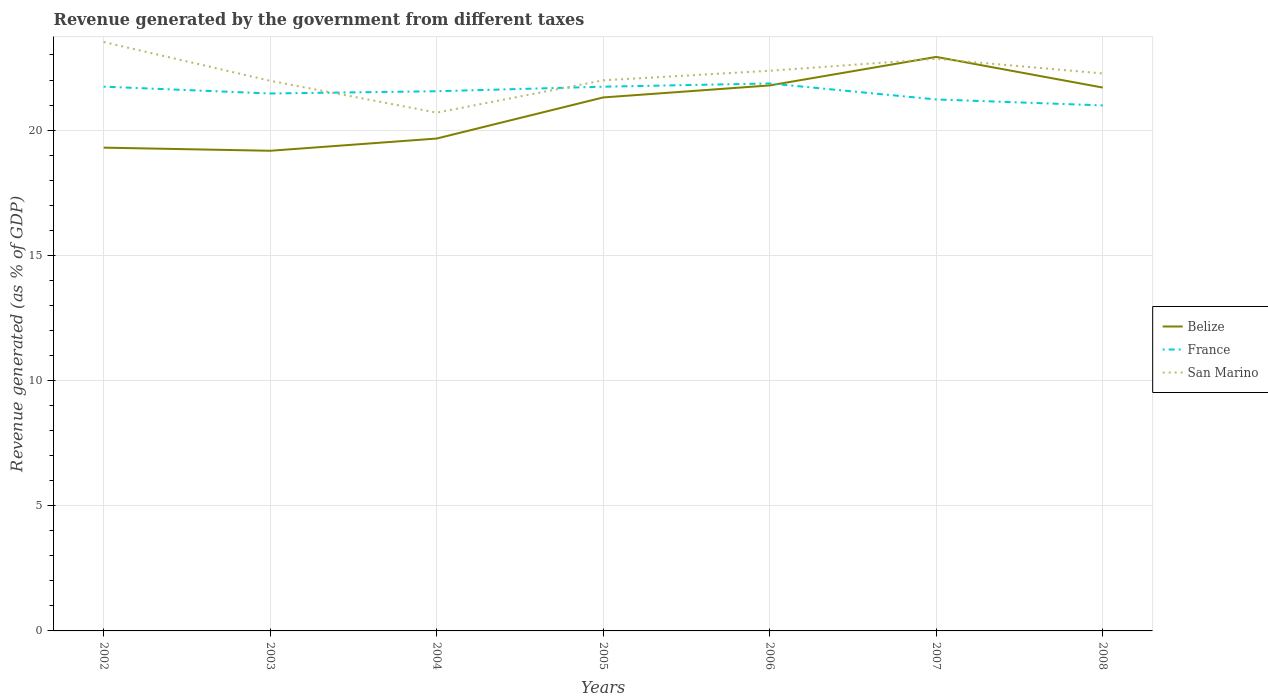Does the line corresponding to Belize intersect with the line corresponding to France?
Give a very brief answer. Yes. Across all years, what is the maximum revenue generated by the government in San Marino?
Make the answer very short. 20.7. In which year was the revenue generated by the government in San Marino maximum?
Offer a very short reply. 2004. What is the total revenue generated by the government in France in the graph?
Offer a very short reply. 0.64. What is the difference between the highest and the second highest revenue generated by the government in San Marino?
Provide a short and direct response. 2.82. How many lines are there?
Give a very brief answer. 3. What is the difference between two consecutive major ticks on the Y-axis?
Your answer should be compact. 5. Does the graph contain any zero values?
Your answer should be compact. No. Does the graph contain grids?
Your response must be concise. Yes. Where does the legend appear in the graph?
Ensure brevity in your answer.  Center right. How many legend labels are there?
Give a very brief answer. 3. How are the legend labels stacked?
Your answer should be very brief. Vertical. What is the title of the graph?
Offer a terse response. Revenue generated by the government from different taxes. What is the label or title of the Y-axis?
Your response must be concise. Revenue generated (as % of GDP). What is the Revenue generated (as % of GDP) in Belize in 2002?
Provide a succinct answer. 19.3. What is the Revenue generated (as % of GDP) of France in 2002?
Your answer should be compact. 21.74. What is the Revenue generated (as % of GDP) of San Marino in 2002?
Ensure brevity in your answer.  23.52. What is the Revenue generated (as % of GDP) in Belize in 2003?
Keep it short and to the point. 19.17. What is the Revenue generated (as % of GDP) of France in 2003?
Offer a terse response. 21.46. What is the Revenue generated (as % of GDP) of San Marino in 2003?
Your response must be concise. 21.97. What is the Revenue generated (as % of GDP) of Belize in 2004?
Ensure brevity in your answer.  19.66. What is the Revenue generated (as % of GDP) of France in 2004?
Your answer should be very brief. 21.55. What is the Revenue generated (as % of GDP) of San Marino in 2004?
Offer a very short reply. 20.7. What is the Revenue generated (as % of GDP) of Belize in 2005?
Your answer should be very brief. 21.3. What is the Revenue generated (as % of GDP) in France in 2005?
Your answer should be very brief. 21.73. What is the Revenue generated (as % of GDP) of San Marino in 2005?
Your response must be concise. 21.99. What is the Revenue generated (as % of GDP) of Belize in 2006?
Your answer should be compact. 21.78. What is the Revenue generated (as % of GDP) of France in 2006?
Ensure brevity in your answer.  21.86. What is the Revenue generated (as % of GDP) of San Marino in 2006?
Keep it short and to the point. 22.37. What is the Revenue generated (as % of GDP) of Belize in 2007?
Offer a terse response. 22.92. What is the Revenue generated (as % of GDP) of France in 2007?
Your response must be concise. 21.22. What is the Revenue generated (as % of GDP) of San Marino in 2007?
Keep it short and to the point. 22.85. What is the Revenue generated (as % of GDP) in Belize in 2008?
Provide a short and direct response. 21.7. What is the Revenue generated (as % of GDP) in France in 2008?
Provide a succinct answer. 20.99. What is the Revenue generated (as % of GDP) in San Marino in 2008?
Make the answer very short. 22.26. Across all years, what is the maximum Revenue generated (as % of GDP) of Belize?
Provide a short and direct response. 22.92. Across all years, what is the maximum Revenue generated (as % of GDP) of France?
Offer a very short reply. 21.86. Across all years, what is the maximum Revenue generated (as % of GDP) of San Marino?
Make the answer very short. 23.52. Across all years, what is the minimum Revenue generated (as % of GDP) of Belize?
Offer a very short reply. 19.17. Across all years, what is the minimum Revenue generated (as % of GDP) of France?
Make the answer very short. 20.99. Across all years, what is the minimum Revenue generated (as % of GDP) in San Marino?
Your answer should be compact. 20.7. What is the total Revenue generated (as % of GDP) in Belize in the graph?
Your response must be concise. 145.85. What is the total Revenue generated (as % of GDP) of France in the graph?
Make the answer very short. 150.56. What is the total Revenue generated (as % of GDP) of San Marino in the graph?
Give a very brief answer. 155.65. What is the difference between the Revenue generated (as % of GDP) in Belize in 2002 and that in 2003?
Offer a very short reply. 0.12. What is the difference between the Revenue generated (as % of GDP) in France in 2002 and that in 2003?
Make the answer very short. 0.27. What is the difference between the Revenue generated (as % of GDP) in San Marino in 2002 and that in 2003?
Give a very brief answer. 1.55. What is the difference between the Revenue generated (as % of GDP) of Belize in 2002 and that in 2004?
Your answer should be compact. -0.36. What is the difference between the Revenue generated (as % of GDP) in France in 2002 and that in 2004?
Make the answer very short. 0.18. What is the difference between the Revenue generated (as % of GDP) of San Marino in 2002 and that in 2004?
Make the answer very short. 2.82. What is the difference between the Revenue generated (as % of GDP) of Belize in 2002 and that in 2005?
Make the answer very short. -2. What is the difference between the Revenue generated (as % of GDP) in France in 2002 and that in 2005?
Your answer should be compact. 0. What is the difference between the Revenue generated (as % of GDP) of San Marino in 2002 and that in 2005?
Give a very brief answer. 1.53. What is the difference between the Revenue generated (as % of GDP) in Belize in 2002 and that in 2006?
Offer a very short reply. -2.48. What is the difference between the Revenue generated (as % of GDP) of France in 2002 and that in 2006?
Give a very brief answer. -0.13. What is the difference between the Revenue generated (as % of GDP) in San Marino in 2002 and that in 2006?
Provide a short and direct response. 1.15. What is the difference between the Revenue generated (as % of GDP) of Belize in 2002 and that in 2007?
Your answer should be compact. -3.62. What is the difference between the Revenue generated (as % of GDP) of France in 2002 and that in 2007?
Keep it short and to the point. 0.51. What is the difference between the Revenue generated (as % of GDP) of San Marino in 2002 and that in 2007?
Your answer should be compact. 0.67. What is the difference between the Revenue generated (as % of GDP) of Belize in 2002 and that in 2008?
Provide a succinct answer. -2.4. What is the difference between the Revenue generated (as % of GDP) of France in 2002 and that in 2008?
Your response must be concise. 0.75. What is the difference between the Revenue generated (as % of GDP) of San Marino in 2002 and that in 2008?
Provide a short and direct response. 1.26. What is the difference between the Revenue generated (as % of GDP) of Belize in 2003 and that in 2004?
Make the answer very short. -0.49. What is the difference between the Revenue generated (as % of GDP) of France in 2003 and that in 2004?
Offer a very short reply. -0.09. What is the difference between the Revenue generated (as % of GDP) of San Marino in 2003 and that in 2004?
Offer a very short reply. 1.27. What is the difference between the Revenue generated (as % of GDP) of Belize in 2003 and that in 2005?
Keep it short and to the point. -2.13. What is the difference between the Revenue generated (as % of GDP) in France in 2003 and that in 2005?
Keep it short and to the point. -0.27. What is the difference between the Revenue generated (as % of GDP) in San Marino in 2003 and that in 2005?
Your answer should be very brief. -0.02. What is the difference between the Revenue generated (as % of GDP) of Belize in 2003 and that in 2006?
Offer a terse response. -2.61. What is the difference between the Revenue generated (as % of GDP) in France in 2003 and that in 2006?
Give a very brief answer. -0.4. What is the difference between the Revenue generated (as % of GDP) in San Marino in 2003 and that in 2006?
Provide a short and direct response. -0.4. What is the difference between the Revenue generated (as % of GDP) of Belize in 2003 and that in 2007?
Your answer should be very brief. -3.75. What is the difference between the Revenue generated (as % of GDP) of France in 2003 and that in 2007?
Your response must be concise. 0.24. What is the difference between the Revenue generated (as % of GDP) in San Marino in 2003 and that in 2007?
Your answer should be very brief. -0.88. What is the difference between the Revenue generated (as % of GDP) in Belize in 2003 and that in 2008?
Ensure brevity in your answer.  -2.52. What is the difference between the Revenue generated (as % of GDP) of France in 2003 and that in 2008?
Provide a short and direct response. 0.48. What is the difference between the Revenue generated (as % of GDP) in San Marino in 2003 and that in 2008?
Give a very brief answer. -0.29. What is the difference between the Revenue generated (as % of GDP) in Belize in 2004 and that in 2005?
Your answer should be very brief. -1.64. What is the difference between the Revenue generated (as % of GDP) in France in 2004 and that in 2005?
Give a very brief answer. -0.18. What is the difference between the Revenue generated (as % of GDP) in San Marino in 2004 and that in 2005?
Your answer should be compact. -1.29. What is the difference between the Revenue generated (as % of GDP) in Belize in 2004 and that in 2006?
Ensure brevity in your answer.  -2.12. What is the difference between the Revenue generated (as % of GDP) of France in 2004 and that in 2006?
Your answer should be very brief. -0.31. What is the difference between the Revenue generated (as % of GDP) of San Marino in 2004 and that in 2006?
Offer a terse response. -1.67. What is the difference between the Revenue generated (as % of GDP) in Belize in 2004 and that in 2007?
Offer a terse response. -3.26. What is the difference between the Revenue generated (as % of GDP) of France in 2004 and that in 2007?
Your answer should be compact. 0.33. What is the difference between the Revenue generated (as % of GDP) in San Marino in 2004 and that in 2007?
Ensure brevity in your answer.  -2.15. What is the difference between the Revenue generated (as % of GDP) of Belize in 2004 and that in 2008?
Your answer should be compact. -2.04. What is the difference between the Revenue generated (as % of GDP) in France in 2004 and that in 2008?
Offer a terse response. 0.57. What is the difference between the Revenue generated (as % of GDP) in San Marino in 2004 and that in 2008?
Ensure brevity in your answer.  -1.56. What is the difference between the Revenue generated (as % of GDP) of Belize in 2005 and that in 2006?
Offer a terse response. -0.48. What is the difference between the Revenue generated (as % of GDP) of France in 2005 and that in 2006?
Offer a very short reply. -0.13. What is the difference between the Revenue generated (as % of GDP) of San Marino in 2005 and that in 2006?
Offer a very short reply. -0.38. What is the difference between the Revenue generated (as % of GDP) in Belize in 2005 and that in 2007?
Keep it short and to the point. -1.62. What is the difference between the Revenue generated (as % of GDP) in France in 2005 and that in 2007?
Give a very brief answer. 0.51. What is the difference between the Revenue generated (as % of GDP) of San Marino in 2005 and that in 2007?
Make the answer very short. -0.86. What is the difference between the Revenue generated (as % of GDP) of Belize in 2005 and that in 2008?
Provide a short and direct response. -0.39. What is the difference between the Revenue generated (as % of GDP) in France in 2005 and that in 2008?
Make the answer very short. 0.75. What is the difference between the Revenue generated (as % of GDP) in San Marino in 2005 and that in 2008?
Keep it short and to the point. -0.27. What is the difference between the Revenue generated (as % of GDP) in Belize in 2006 and that in 2007?
Your response must be concise. -1.14. What is the difference between the Revenue generated (as % of GDP) of France in 2006 and that in 2007?
Ensure brevity in your answer.  0.64. What is the difference between the Revenue generated (as % of GDP) of San Marino in 2006 and that in 2007?
Your answer should be very brief. -0.48. What is the difference between the Revenue generated (as % of GDP) in Belize in 2006 and that in 2008?
Ensure brevity in your answer.  0.09. What is the difference between the Revenue generated (as % of GDP) of France in 2006 and that in 2008?
Make the answer very short. 0.88. What is the difference between the Revenue generated (as % of GDP) of San Marino in 2006 and that in 2008?
Your answer should be very brief. 0.11. What is the difference between the Revenue generated (as % of GDP) in Belize in 2007 and that in 2008?
Provide a short and direct response. 1.22. What is the difference between the Revenue generated (as % of GDP) of France in 2007 and that in 2008?
Ensure brevity in your answer.  0.24. What is the difference between the Revenue generated (as % of GDP) of San Marino in 2007 and that in 2008?
Provide a short and direct response. 0.58. What is the difference between the Revenue generated (as % of GDP) in Belize in 2002 and the Revenue generated (as % of GDP) in France in 2003?
Offer a very short reply. -2.16. What is the difference between the Revenue generated (as % of GDP) of Belize in 2002 and the Revenue generated (as % of GDP) of San Marino in 2003?
Provide a short and direct response. -2.67. What is the difference between the Revenue generated (as % of GDP) in France in 2002 and the Revenue generated (as % of GDP) in San Marino in 2003?
Give a very brief answer. -0.23. What is the difference between the Revenue generated (as % of GDP) of Belize in 2002 and the Revenue generated (as % of GDP) of France in 2004?
Ensure brevity in your answer.  -2.25. What is the difference between the Revenue generated (as % of GDP) in Belize in 2002 and the Revenue generated (as % of GDP) in San Marino in 2004?
Your answer should be very brief. -1.4. What is the difference between the Revenue generated (as % of GDP) in France in 2002 and the Revenue generated (as % of GDP) in San Marino in 2004?
Offer a very short reply. 1.04. What is the difference between the Revenue generated (as % of GDP) of Belize in 2002 and the Revenue generated (as % of GDP) of France in 2005?
Ensure brevity in your answer.  -2.43. What is the difference between the Revenue generated (as % of GDP) in Belize in 2002 and the Revenue generated (as % of GDP) in San Marino in 2005?
Your answer should be very brief. -2.69. What is the difference between the Revenue generated (as % of GDP) in France in 2002 and the Revenue generated (as % of GDP) in San Marino in 2005?
Keep it short and to the point. -0.25. What is the difference between the Revenue generated (as % of GDP) of Belize in 2002 and the Revenue generated (as % of GDP) of France in 2006?
Give a very brief answer. -2.56. What is the difference between the Revenue generated (as % of GDP) in Belize in 2002 and the Revenue generated (as % of GDP) in San Marino in 2006?
Ensure brevity in your answer.  -3.07. What is the difference between the Revenue generated (as % of GDP) in France in 2002 and the Revenue generated (as % of GDP) in San Marino in 2006?
Keep it short and to the point. -0.63. What is the difference between the Revenue generated (as % of GDP) in Belize in 2002 and the Revenue generated (as % of GDP) in France in 2007?
Your answer should be very brief. -1.92. What is the difference between the Revenue generated (as % of GDP) in Belize in 2002 and the Revenue generated (as % of GDP) in San Marino in 2007?
Keep it short and to the point. -3.55. What is the difference between the Revenue generated (as % of GDP) of France in 2002 and the Revenue generated (as % of GDP) of San Marino in 2007?
Provide a short and direct response. -1.11. What is the difference between the Revenue generated (as % of GDP) of Belize in 2002 and the Revenue generated (as % of GDP) of France in 2008?
Your answer should be compact. -1.69. What is the difference between the Revenue generated (as % of GDP) of Belize in 2002 and the Revenue generated (as % of GDP) of San Marino in 2008?
Offer a very short reply. -2.96. What is the difference between the Revenue generated (as % of GDP) in France in 2002 and the Revenue generated (as % of GDP) in San Marino in 2008?
Make the answer very short. -0.53. What is the difference between the Revenue generated (as % of GDP) of Belize in 2003 and the Revenue generated (as % of GDP) of France in 2004?
Your answer should be very brief. -2.38. What is the difference between the Revenue generated (as % of GDP) in Belize in 2003 and the Revenue generated (as % of GDP) in San Marino in 2004?
Keep it short and to the point. -1.52. What is the difference between the Revenue generated (as % of GDP) of France in 2003 and the Revenue generated (as % of GDP) of San Marino in 2004?
Provide a short and direct response. 0.76. What is the difference between the Revenue generated (as % of GDP) in Belize in 2003 and the Revenue generated (as % of GDP) in France in 2005?
Your response must be concise. -2.56. What is the difference between the Revenue generated (as % of GDP) in Belize in 2003 and the Revenue generated (as % of GDP) in San Marino in 2005?
Give a very brief answer. -2.81. What is the difference between the Revenue generated (as % of GDP) of France in 2003 and the Revenue generated (as % of GDP) of San Marino in 2005?
Make the answer very short. -0.53. What is the difference between the Revenue generated (as % of GDP) in Belize in 2003 and the Revenue generated (as % of GDP) in France in 2006?
Offer a very short reply. -2.69. What is the difference between the Revenue generated (as % of GDP) of Belize in 2003 and the Revenue generated (as % of GDP) of San Marino in 2006?
Your answer should be compact. -3.2. What is the difference between the Revenue generated (as % of GDP) of France in 2003 and the Revenue generated (as % of GDP) of San Marino in 2006?
Your answer should be compact. -0.91. What is the difference between the Revenue generated (as % of GDP) of Belize in 2003 and the Revenue generated (as % of GDP) of France in 2007?
Keep it short and to the point. -2.05. What is the difference between the Revenue generated (as % of GDP) in Belize in 2003 and the Revenue generated (as % of GDP) in San Marino in 2007?
Offer a very short reply. -3.67. What is the difference between the Revenue generated (as % of GDP) in France in 2003 and the Revenue generated (as % of GDP) in San Marino in 2007?
Ensure brevity in your answer.  -1.38. What is the difference between the Revenue generated (as % of GDP) of Belize in 2003 and the Revenue generated (as % of GDP) of France in 2008?
Offer a very short reply. -1.81. What is the difference between the Revenue generated (as % of GDP) of Belize in 2003 and the Revenue generated (as % of GDP) of San Marino in 2008?
Your answer should be very brief. -3.09. What is the difference between the Revenue generated (as % of GDP) of France in 2003 and the Revenue generated (as % of GDP) of San Marino in 2008?
Provide a short and direct response. -0.8. What is the difference between the Revenue generated (as % of GDP) in Belize in 2004 and the Revenue generated (as % of GDP) in France in 2005?
Your answer should be very brief. -2.07. What is the difference between the Revenue generated (as % of GDP) in Belize in 2004 and the Revenue generated (as % of GDP) in San Marino in 2005?
Offer a very short reply. -2.32. What is the difference between the Revenue generated (as % of GDP) of France in 2004 and the Revenue generated (as % of GDP) of San Marino in 2005?
Keep it short and to the point. -0.44. What is the difference between the Revenue generated (as % of GDP) of Belize in 2004 and the Revenue generated (as % of GDP) of France in 2006?
Offer a very short reply. -2.2. What is the difference between the Revenue generated (as % of GDP) in Belize in 2004 and the Revenue generated (as % of GDP) in San Marino in 2006?
Ensure brevity in your answer.  -2.71. What is the difference between the Revenue generated (as % of GDP) of France in 2004 and the Revenue generated (as % of GDP) of San Marino in 2006?
Provide a succinct answer. -0.82. What is the difference between the Revenue generated (as % of GDP) of Belize in 2004 and the Revenue generated (as % of GDP) of France in 2007?
Give a very brief answer. -1.56. What is the difference between the Revenue generated (as % of GDP) of Belize in 2004 and the Revenue generated (as % of GDP) of San Marino in 2007?
Offer a very short reply. -3.18. What is the difference between the Revenue generated (as % of GDP) in France in 2004 and the Revenue generated (as % of GDP) in San Marino in 2007?
Offer a very short reply. -1.29. What is the difference between the Revenue generated (as % of GDP) of Belize in 2004 and the Revenue generated (as % of GDP) of France in 2008?
Offer a very short reply. -1.32. What is the difference between the Revenue generated (as % of GDP) of Belize in 2004 and the Revenue generated (as % of GDP) of San Marino in 2008?
Provide a succinct answer. -2.6. What is the difference between the Revenue generated (as % of GDP) in France in 2004 and the Revenue generated (as % of GDP) in San Marino in 2008?
Provide a short and direct response. -0.71. What is the difference between the Revenue generated (as % of GDP) in Belize in 2005 and the Revenue generated (as % of GDP) in France in 2006?
Your answer should be very brief. -0.56. What is the difference between the Revenue generated (as % of GDP) in Belize in 2005 and the Revenue generated (as % of GDP) in San Marino in 2006?
Your answer should be compact. -1.07. What is the difference between the Revenue generated (as % of GDP) of France in 2005 and the Revenue generated (as % of GDP) of San Marino in 2006?
Keep it short and to the point. -0.64. What is the difference between the Revenue generated (as % of GDP) of Belize in 2005 and the Revenue generated (as % of GDP) of France in 2007?
Offer a very short reply. 0.08. What is the difference between the Revenue generated (as % of GDP) in Belize in 2005 and the Revenue generated (as % of GDP) in San Marino in 2007?
Your answer should be very brief. -1.54. What is the difference between the Revenue generated (as % of GDP) of France in 2005 and the Revenue generated (as % of GDP) of San Marino in 2007?
Offer a terse response. -1.11. What is the difference between the Revenue generated (as % of GDP) in Belize in 2005 and the Revenue generated (as % of GDP) in France in 2008?
Ensure brevity in your answer.  0.32. What is the difference between the Revenue generated (as % of GDP) of Belize in 2005 and the Revenue generated (as % of GDP) of San Marino in 2008?
Ensure brevity in your answer.  -0.96. What is the difference between the Revenue generated (as % of GDP) of France in 2005 and the Revenue generated (as % of GDP) of San Marino in 2008?
Keep it short and to the point. -0.53. What is the difference between the Revenue generated (as % of GDP) in Belize in 2006 and the Revenue generated (as % of GDP) in France in 2007?
Offer a very short reply. 0.56. What is the difference between the Revenue generated (as % of GDP) in Belize in 2006 and the Revenue generated (as % of GDP) in San Marino in 2007?
Provide a short and direct response. -1.06. What is the difference between the Revenue generated (as % of GDP) in France in 2006 and the Revenue generated (as % of GDP) in San Marino in 2007?
Your response must be concise. -0.98. What is the difference between the Revenue generated (as % of GDP) of Belize in 2006 and the Revenue generated (as % of GDP) of France in 2008?
Your response must be concise. 0.8. What is the difference between the Revenue generated (as % of GDP) in Belize in 2006 and the Revenue generated (as % of GDP) in San Marino in 2008?
Offer a very short reply. -0.48. What is the difference between the Revenue generated (as % of GDP) of France in 2006 and the Revenue generated (as % of GDP) of San Marino in 2008?
Make the answer very short. -0.4. What is the difference between the Revenue generated (as % of GDP) in Belize in 2007 and the Revenue generated (as % of GDP) in France in 2008?
Make the answer very short. 1.94. What is the difference between the Revenue generated (as % of GDP) in Belize in 2007 and the Revenue generated (as % of GDP) in San Marino in 2008?
Your response must be concise. 0.66. What is the difference between the Revenue generated (as % of GDP) of France in 2007 and the Revenue generated (as % of GDP) of San Marino in 2008?
Offer a very short reply. -1.04. What is the average Revenue generated (as % of GDP) in Belize per year?
Provide a succinct answer. 20.84. What is the average Revenue generated (as % of GDP) in France per year?
Offer a terse response. 21.51. What is the average Revenue generated (as % of GDP) in San Marino per year?
Provide a short and direct response. 22.24. In the year 2002, what is the difference between the Revenue generated (as % of GDP) in Belize and Revenue generated (as % of GDP) in France?
Offer a very short reply. -2.44. In the year 2002, what is the difference between the Revenue generated (as % of GDP) in Belize and Revenue generated (as % of GDP) in San Marino?
Keep it short and to the point. -4.22. In the year 2002, what is the difference between the Revenue generated (as % of GDP) in France and Revenue generated (as % of GDP) in San Marino?
Your answer should be compact. -1.78. In the year 2003, what is the difference between the Revenue generated (as % of GDP) of Belize and Revenue generated (as % of GDP) of France?
Your answer should be compact. -2.29. In the year 2003, what is the difference between the Revenue generated (as % of GDP) of Belize and Revenue generated (as % of GDP) of San Marino?
Keep it short and to the point. -2.79. In the year 2003, what is the difference between the Revenue generated (as % of GDP) in France and Revenue generated (as % of GDP) in San Marino?
Give a very brief answer. -0.51. In the year 2004, what is the difference between the Revenue generated (as % of GDP) in Belize and Revenue generated (as % of GDP) in France?
Offer a terse response. -1.89. In the year 2004, what is the difference between the Revenue generated (as % of GDP) in Belize and Revenue generated (as % of GDP) in San Marino?
Provide a short and direct response. -1.03. In the year 2004, what is the difference between the Revenue generated (as % of GDP) in France and Revenue generated (as % of GDP) in San Marino?
Your response must be concise. 0.85. In the year 2005, what is the difference between the Revenue generated (as % of GDP) in Belize and Revenue generated (as % of GDP) in France?
Your answer should be very brief. -0.43. In the year 2005, what is the difference between the Revenue generated (as % of GDP) of Belize and Revenue generated (as % of GDP) of San Marino?
Your answer should be compact. -0.68. In the year 2005, what is the difference between the Revenue generated (as % of GDP) of France and Revenue generated (as % of GDP) of San Marino?
Your response must be concise. -0.25. In the year 2006, what is the difference between the Revenue generated (as % of GDP) in Belize and Revenue generated (as % of GDP) in France?
Your response must be concise. -0.08. In the year 2006, what is the difference between the Revenue generated (as % of GDP) in Belize and Revenue generated (as % of GDP) in San Marino?
Provide a succinct answer. -0.59. In the year 2006, what is the difference between the Revenue generated (as % of GDP) in France and Revenue generated (as % of GDP) in San Marino?
Offer a very short reply. -0.51. In the year 2007, what is the difference between the Revenue generated (as % of GDP) in Belize and Revenue generated (as % of GDP) in France?
Make the answer very short. 1.7. In the year 2007, what is the difference between the Revenue generated (as % of GDP) of Belize and Revenue generated (as % of GDP) of San Marino?
Keep it short and to the point. 0.08. In the year 2007, what is the difference between the Revenue generated (as % of GDP) in France and Revenue generated (as % of GDP) in San Marino?
Offer a terse response. -1.62. In the year 2008, what is the difference between the Revenue generated (as % of GDP) in Belize and Revenue generated (as % of GDP) in France?
Your answer should be very brief. 0.71. In the year 2008, what is the difference between the Revenue generated (as % of GDP) of Belize and Revenue generated (as % of GDP) of San Marino?
Your response must be concise. -0.56. In the year 2008, what is the difference between the Revenue generated (as % of GDP) in France and Revenue generated (as % of GDP) in San Marino?
Keep it short and to the point. -1.28. What is the ratio of the Revenue generated (as % of GDP) of France in 2002 to that in 2003?
Your response must be concise. 1.01. What is the ratio of the Revenue generated (as % of GDP) in San Marino in 2002 to that in 2003?
Ensure brevity in your answer.  1.07. What is the ratio of the Revenue generated (as % of GDP) of Belize in 2002 to that in 2004?
Ensure brevity in your answer.  0.98. What is the ratio of the Revenue generated (as % of GDP) of France in 2002 to that in 2004?
Ensure brevity in your answer.  1.01. What is the ratio of the Revenue generated (as % of GDP) of San Marino in 2002 to that in 2004?
Provide a succinct answer. 1.14. What is the ratio of the Revenue generated (as % of GDP) of Belize in 2002 to that in 2005?
Give a very brief answer. 0.91. What is the ratio of the Revenue generated (as % of GDP) in San Marino in 2002 to that in 2005?
Make the answer very short. 1.07. What is the ratio of the Revenue generated (as % of GDP) of Belize in 2002 to that in 2006?
Keep it short and to the point. 0.89. What is the ratio of the Revenue generated (as % of GDP) in San Marino in 2002 to that in 2006?
Your answer should be very brief. 1.05. What is the ratio of the Revenue generated (as % of GDP) of Belize in 2002 to that in 2007?
Provide a succinct answer. 0.84. What is the ratio of the Revenue generated (as % of GDP) of France in 2002 to that in 2007?
Give a very brief answer. 1.02. What is the ratio of the Revenue generated (as % of GDP) in San Marino in 2002 to that in 2007?
Make the answer very short. 1.03. What is the ratio of the Revenue generated (as % of GDP) in Belize in 2002 to that in 2008?
Provide a short and direct response. 0.89. What is the ratio of the Revenue generated (as % of GDP) of France in 2002 to that in 2008?
Your response must be concise. 1.04. What is the ratio of the Revenue generated (as % of GDP) in San Marino in 2002 to that in 2008?
Give a very brief answer. 1.06. What is the ratio of the Revenue generated (as % of GDP) of Belize in 2003 to that in 2004?
Ensure brevity in your answer.  0.98. What is the ratio of the Revenue generated (as % of GDP) of San Marino in 2003 to that in 2004?
Your answer should be very brief. 1.06. What is the ratio of the Revenue generated (as % of GDP) in Belize in 2003 to that in 2005?
Your response must be concise. 0.9. What is the ratio of the Revenue generated (as % of GDP) in France in 2003 to that in 2005?
Your response must be concise. 0.99. What is the ratio of the Revenue generated (as % of GDP) in Belize in 2003 to that in 2006?
Make the answer very short. 0.88. What is the ratio of the Revenue generated (as % of GDP) of France in 2003 to that in 2006?
Provide a succinct answer. 0.98. What is the ratio of the Revenue generated (as % of GDP) in San Marino in 2003 to that in 2006?
Your response must be concise. 0.98. What is the ratio of the Revenue generated (as % of GDP) in Belize in 2003 to that in 2007?
Offer a terse response. 0.84. What is the ratio of the Revenue generated (as % of GDP) in France in 2003 to that in 2007?
Keep it short and to the point. 1.01. What is the ratio of the Revenue generated (as % of GDP) in San Marino in 2003 to that in 2007?
Ensure brevity in your answer.  0.96. What is the ratio of the Revenue generated (as % of GDP) of Belize in 2003 to that in 2008?
Your answer should be compact. 0.88. What is the ratio of the Revenue generated (as % of GDP) of France in 2003 to that in 2008?
Your response must be concise. 1.02. What is the ratio of the Revenue generated (as % of GDP) of Belize in 2004 to that in 2005?
Provide a short and direct response. 0.92. What is the ratio of the Revenue generated (as % of GDP) in France in 2004 to that in 2005?
Offer a very short reply. 0.99. What is the ratio of the Revenue generated (as % of GDP) of San Marino in 2004 to that in 2005?
Your response must be concise. 0.94. What is the ratio of the Revenue generated (as % of GDP) in Belize in 2004 to that in 2006?
Give a very brief answer. 0.9. What is the ratio of the Revenue generated (as % of GDP) in France in 2004 to that in 2006?
Provide a short and direct response. 0.99. What is the ratio of the Revenue generated (as % of GDP) in San Marino in 2004 to that in 2006?
Offer a very short reply. 0.93. What is the ratio of the Revenue generated (as % of GDP) of Belize in 2004 to that in 2007?
Your answer should be compact. 0.86. What is the ratio of the Revenue generated (as % of GDP) of France in 2004 to that in 2007?
Ensure brevity in your answer.  1.02. What is the ratio of the Revenue generated (as % of GDP) of San Marino in 2004 to that in 2007?
Your response must be concise. 0.91. What is the ratio of the Revenue generated (as % of GDP) in Belize in 2004 to that in 2008?
Offer a terse response. 0.91. What is the ratio of the Revenue generated (as % of GDP) in France in 2004 to that in 2008?
Make the answer very short. 1.03. What is the ratio of the Revenue generated (as % of GDP) of San Marino in 2004 to that in 2008?
Offer a terse response. 0.93. What is the ratio of the Revenue generated (as % of GDP) in France in 2005 to that in 2006?
Ensure brevity in your answer.  0.99. What is the ratio of the Revenue generated (as % of GDP) of San Marino in 2005 to that in 2006?
Ensure brevity in your answer.  0.98. What is the ratio of the Revenue generated (as % of GDP) in Belize in 2005 to that in 2007?
Give a very brief answer. 0.93. What is the ratio of the Revenue generated (as % of GDP) of France in 2005 to that in 2007?
Give a very brief answer. 1.02. What is the ratio of the Revenue generated (as % of GDP) in San Marino in 2005 to that in 2007?
Ensure brevity in your answer.  0.96. What is the ratio of the Revenue generated (as % of GDP) of Belize in 2005 to that in 2008?
Your answer should be compact. 0.98. What is the ratio of the Revenue generated (as % of GDP) in France in 2005 to that in 2008?
Your answer should be compact. 1.04. What is the ratio of the Revenue generated (as % of GDP) of San Marino in 2005 to that in 2008?
Your answer should be compact. 0.99. What is the ratio of the Revenue generated (as % of GDP) in Belize in 2006 to that in 2007?
Give a very brief answer. 0.95. What is the ratio of the Revenue generated (as % of GDP) in France in 2006 to that in 2007?
Make the answer very short. 1.03. What is the ratio of the Revenue generated (as % of GDP) in San Marino in 2006 to that in 2007?
Provide a succinct answer. 0.98. What is the ratio of the Revenue generated (as % of GDP) of France in 2006 to that in 2008?
Your answer should be compact. 1.04. What is the ratio of the Revenue generated (as % of GDP) of Belize in 2007 to that in 2008?
Offer a terse response. 1.06. What is the ratio of the Revenue generated (as % of GDP) of France in 2007 to that in 2008?
Your response must be concise. 1.01. What is the ratio of the Revenue generated (as % of GDP) of San Marino in 2007 to that in 2008?
Give a very brief answer. 1.03. What is the difference between the highest and the second highest Revenue generated (as % of GDP) in Belize?
Offer a very short reply. 1.14. What is the difference between the highest and the second highest Revenue generated (as % of GDP) of France?
Offer a very short reply. 0.13. What is the difference between the highest and the second highest Revenue generated (as % of GDP) in San Marino?
Provide a succinct answer. 0.67. What is the difference between the highest and the lowest Revenue generated (as % of GDP) of Belize?
Provide a short and direct response. 3.75. What is the difference between the highest and the lowest Revenue generated (as % of GDP) of France?
Offer a very short reply. 0.88. What is the difference between the highest and the lowest Revenue generated (as % of GDP) in San Marino?
Keep it short and to the point. 2.82. 